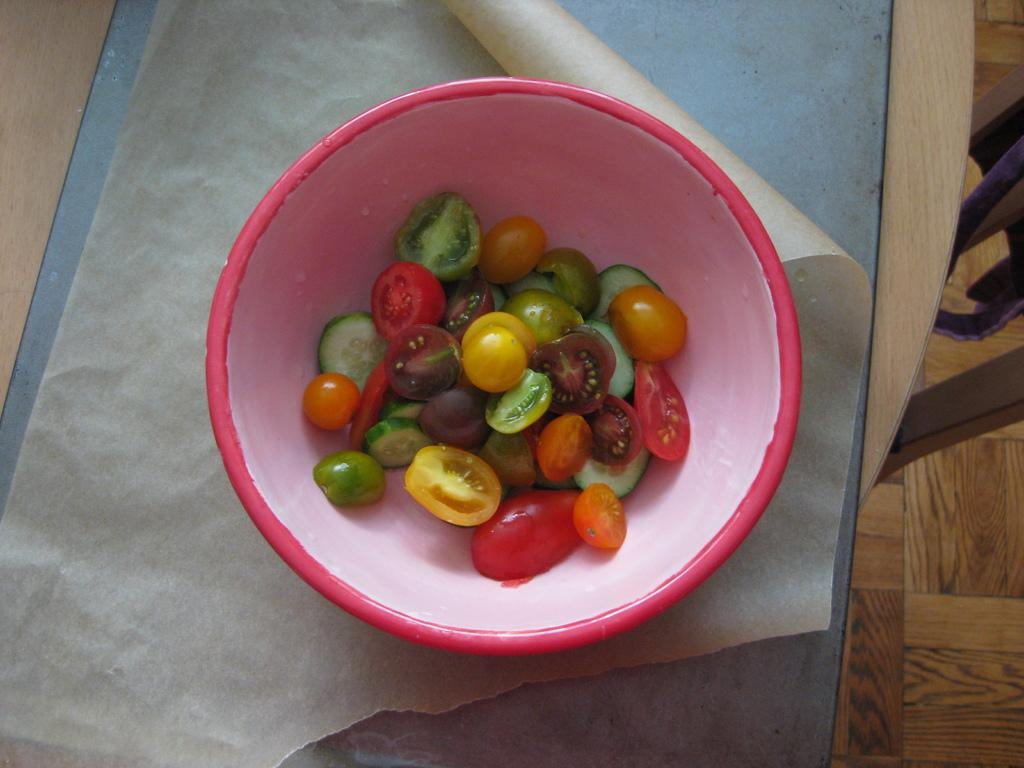What type of food is in the bowl in the image? There are veggies in a bowl in the image. What is covering the table in the image? There is a sheet on the table in the image. What type of furniture is in the image? There is a chair in the image. What part of the room can be seen in the image? The floor is visible in the image. How many fish are swimming in the bowl in the image? There are no fish present in the image; it features a bowl of veggies. What type of attraction is visible in the image? There is no attraction present in the image; it shows a bowl of veggies, a sheet on the table, a chair, and the floor. 